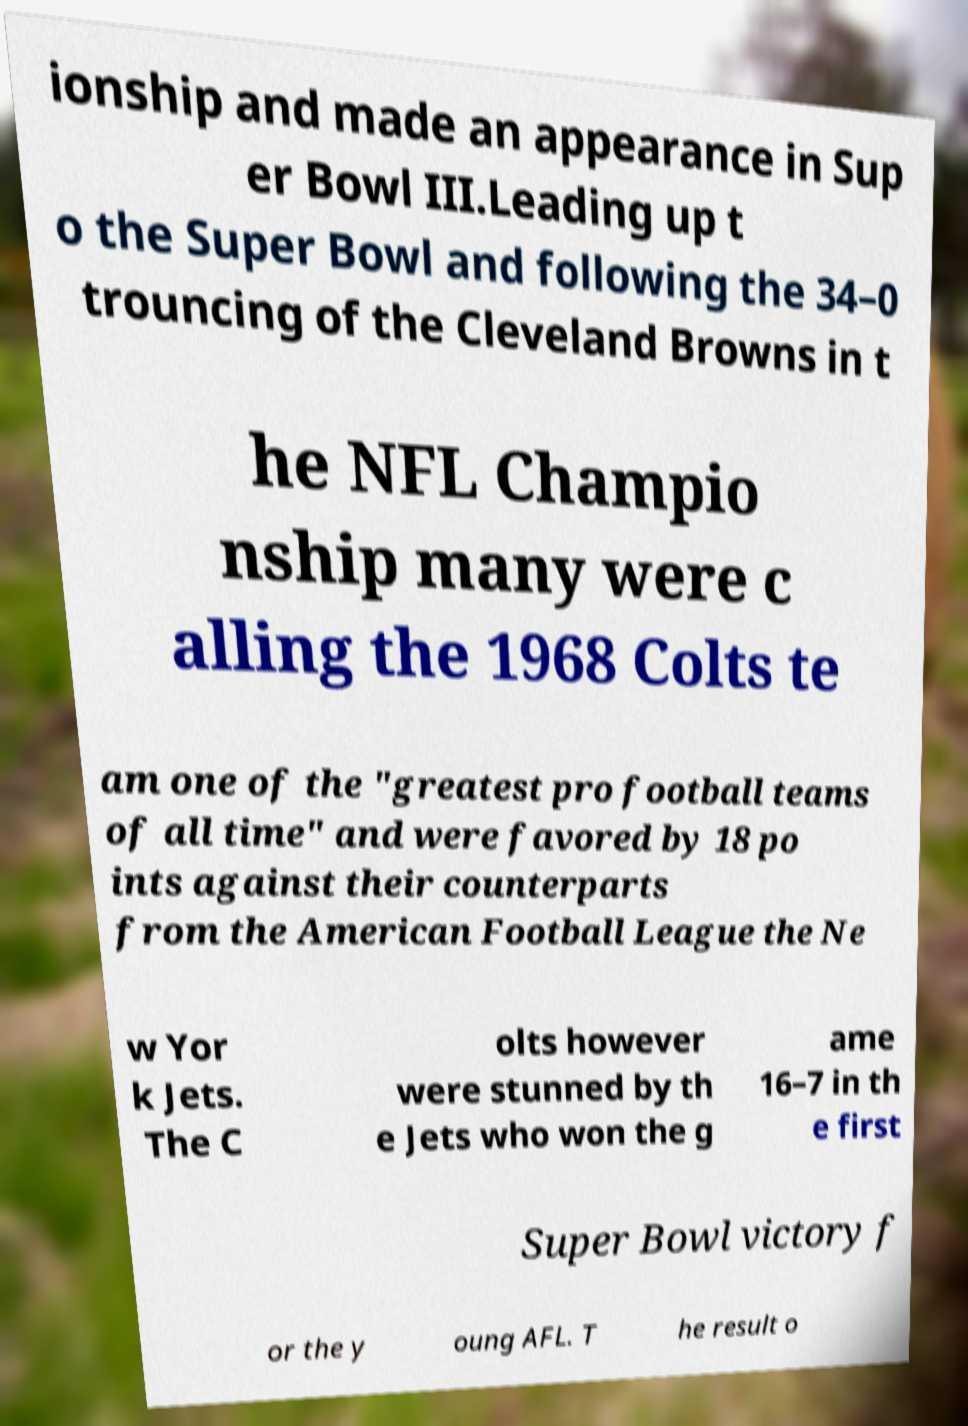Could you extract and type out the text from this image? ionship and made an appearance in Sup er Bowl III.Leading up t o the Super Bowl and following the 34–0 trouncing of the Cleveland Browns in t he NFL Champio nship many were c alling the 1968 Colts te am one of the "greatest pro football teams of all time" and were favored by 18 po ints against their counterparts from the American Football League the Ne w Yor k Jets. The C olts however were stunned by th e Jets who won the g ame 16–7 in th e first Super Bowl victory f or the y oung AFL. T he result o 